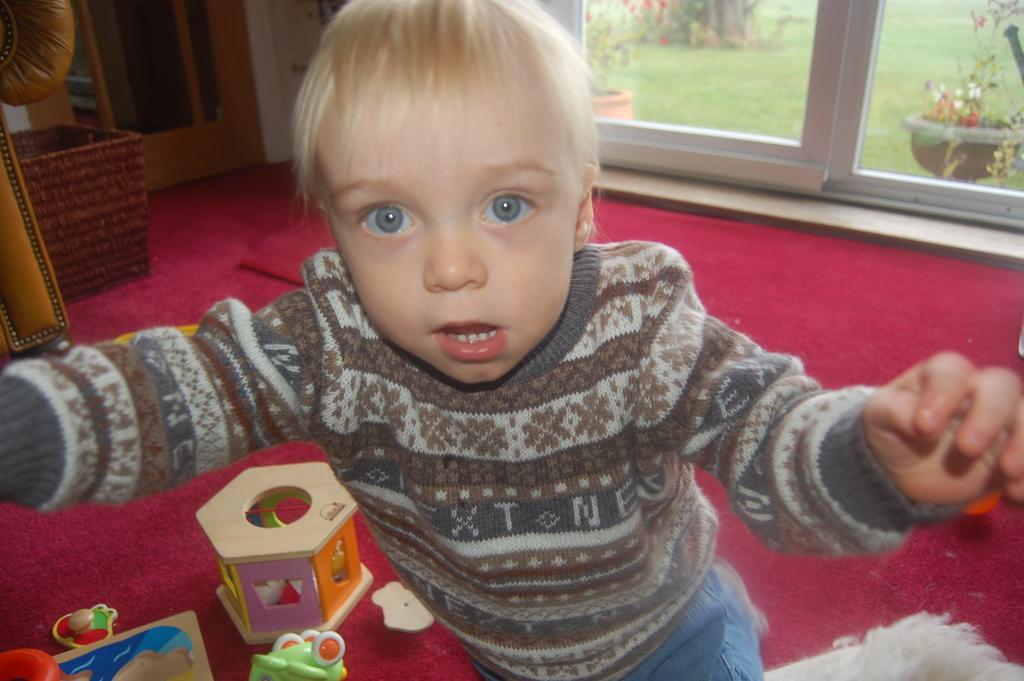Describe this image in one or two sentences. In this image we can see a kid and there are toys placed on the carpet. On the left there is a sofa and a stool. There are doors and we can see plants and grass through the glass door. 